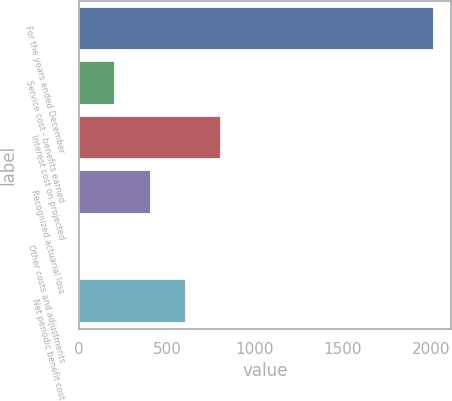Convert chart. <chart><loc_0><loc_0><loc_500><loc_500><bar_chart><fcel>For the years ended December<fcel>Service cost - benefits earned<fcel>Interest cost on projected<fcel>Recognized actuarial loss<fcel>Other costs and adjustments<fcel>Net periodic benefit cost<nl><fcel>2016<fcel>205.2<fcel>808.8<fcel>406.4<fcel>4<fcel>607.6<nl></chart> 